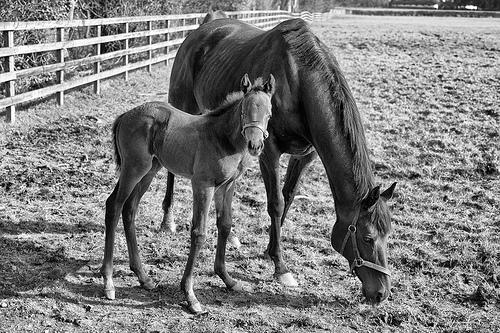Analyze the interaction between the two main subjects in the image. The mare and foal seem to be bonding, as the colt stands close to its mother while both are grazing on sparse grass. Briefly describe what the mare is doing in the image. The mare is eating grass in a fenced-in area, appearing skinny with its ribs showing. Judge the quality of the image based on the clarity and details of the objects. The image quality is good, with clear representation and details of the mare, foal, fencing, and grass patches. How many horses are in the image, and what are their conditions? There are two horses, a mare and a foal, both with their ribs showing and looking skinny. Identify the primary components of the image depicting objects related to the animals. There are a mare and a foal, both wearing halters, inside a wooden fenced horse pen with sparse grass. What is the condition of the grass in the image? The grass is sparse, with several sections across the fenced-in area. Mention the main scene in the image, along with the animals present. The image shows a mare and her foal in a fenced-in area, with both horses appearing skinny and grazing on sparse grass. What are the notable physical features of the foal in the image? The foal has a light-colored coat, long legs, a dark-colored mane, and is wearing a halter. What type of emotion or mood does the image convey? The image conveys a feeling of concern and compassion for the skinny mare and foal in a sparse grass area. Count the number of visible grass patches on the field. There are nine visible grass patches in the image. 